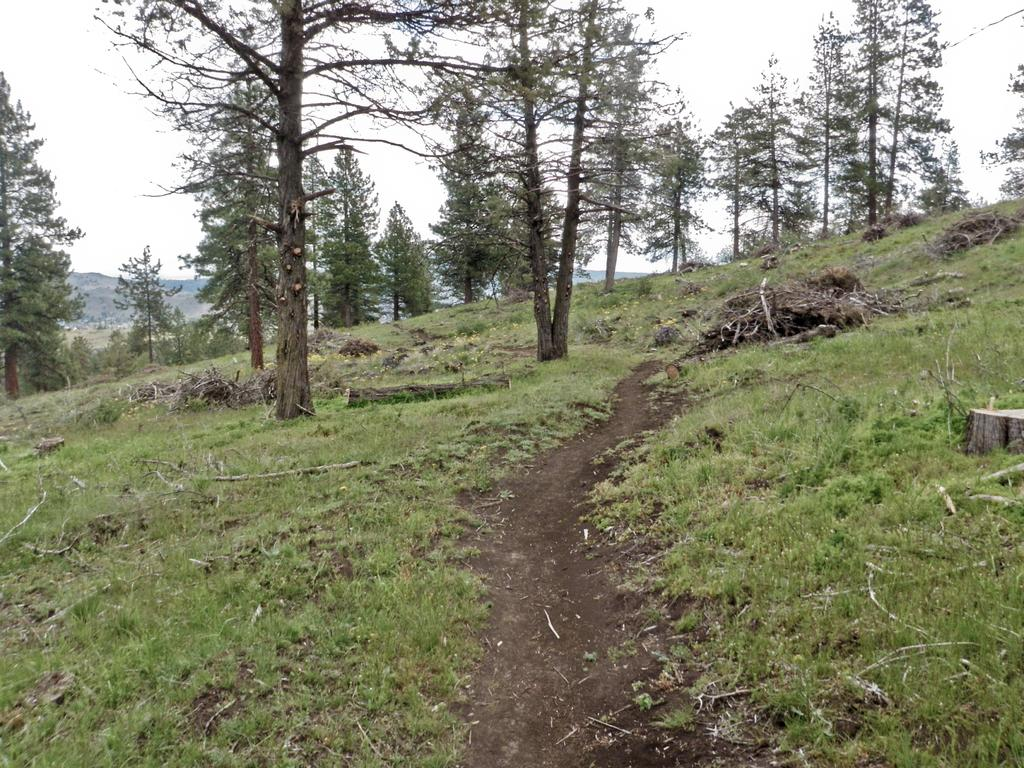What type of vegetation is present in the image? There are many trees in the image. What is covering the ground in the image? There is grass on the ground in the image. What can be seen in the distance in the image? There are mountains in the background of the image. What is the color of the sky in the image? The sky is white in the image. Can you see a ray of light shining through the trees in the image? There is no mention of a ray of light in the provided facts, so we cannot determine if it is present in the image. 